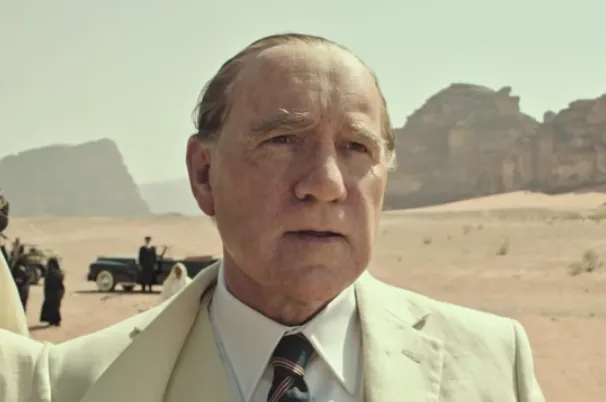Describe the following image. The image captures actor Christopher Plummer in his role as J. Paul Getty in the film 'All the Money in the World.' He is depicted standing alone in a boundless desert landscape, symbolizing isolation amidst vast wealth. Dressed in a light-colored suit, accessorized with a tie and pocket square, he portrays a figure of significant authority and affluence. In the background, a classic car and a few people hint at unfolding events, suggesting a narrative that extends beyond the immediate scene. Plummer's expression is solemn and contemplative, reflecting the weight of his character's predicament in the story. 